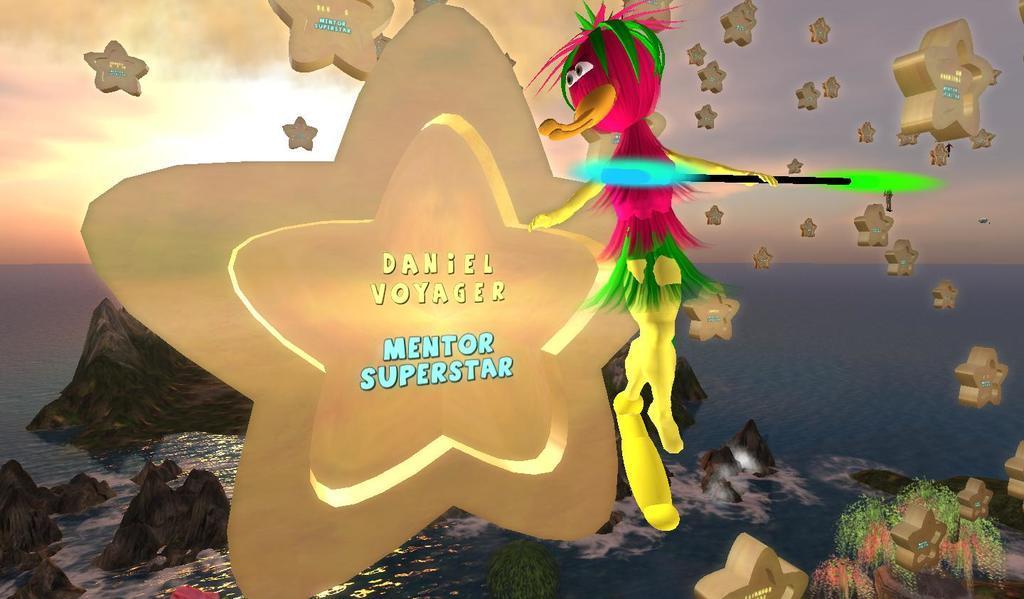Can you describe this image briefly? This is an animated image. We can see some water with a few rocks. We can also see some stars and a toy. We can see some plants and the sky. 